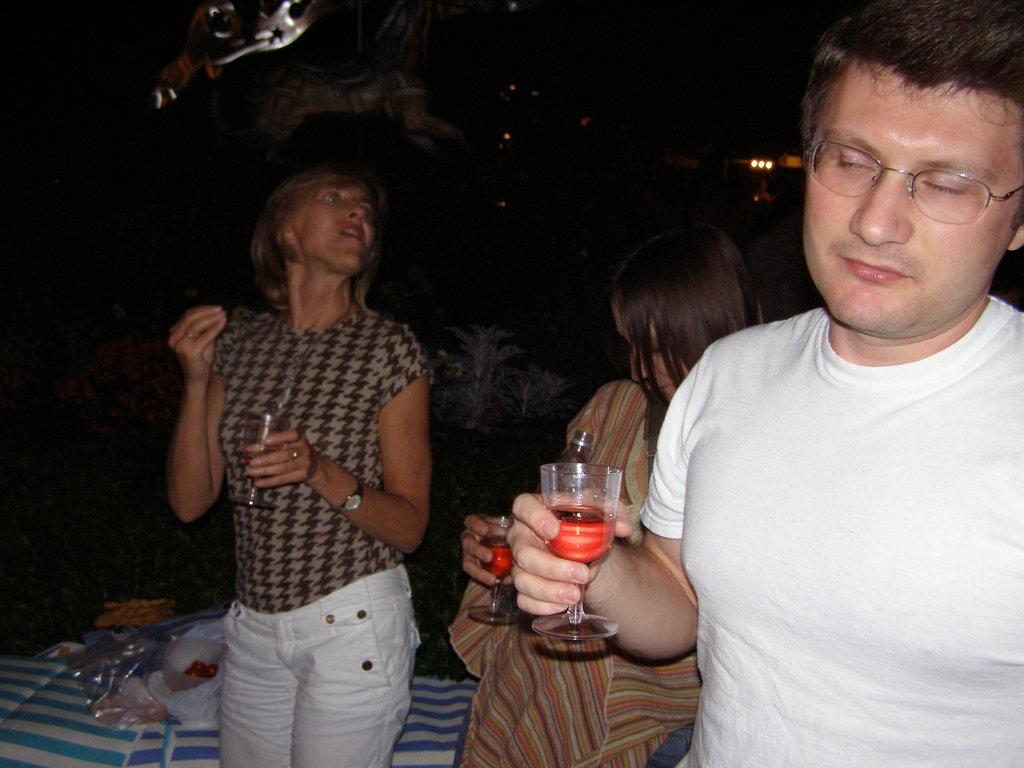How many people are in the image? There are three people in the image. What is one person doing in the image? One person is drinking a drink. How many women are in the image? There are two women in the image. What can be observed about the background of the image? The background is dark. What type of wax can be seen melting in the image? There is no wax present in the image. What season is depicted in the image? The provided facts do not mention any season or time of year, so it cannot be determined from the image. 